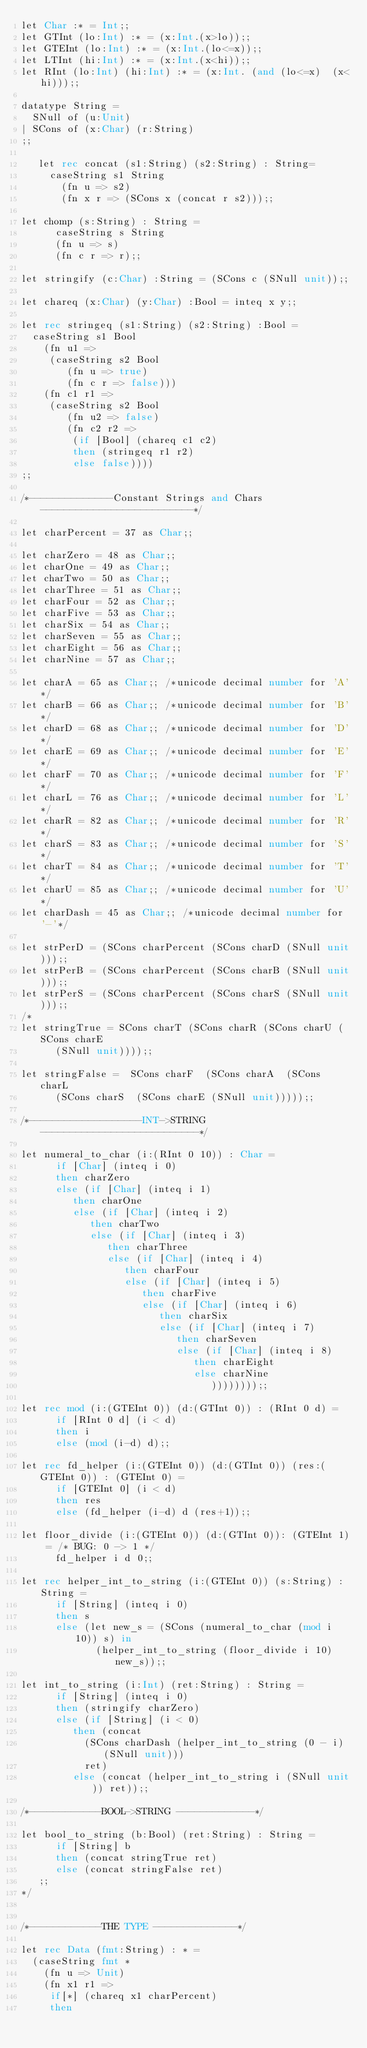Convert code to text. <code><loc_0><loc_0><loc_500><loc_500><_FORTRAN_>let Char :* = Int;;
let GTInt (lo:Int) :* = (x:Int.(x>lo));;
let GTEInt (lo:Int) :* = (x:Int.(lo<=x));;
let LTInt (hi:Int) :* = (x:Int.(x<hi));; 
let RInt (lo:Int) (hi:Int) :* = (x:Int. (and (lo<=x)  (x<hi)));;

datatype String =
  SNull of (u:Unit)
| SCons of (x:Char) (r:String)
;;
   
   let rec concat (s1:String) (s2:String) : String=
     caseString s1 String
       (fn u => s2)
       (fn x r => (SCons x (concat r s2)));;

let chomp (s:String) : String =
      caseString s String
      (fn u => s)
      (fn c r => r);;  

let stringify (c:Char) :String = (SCons c (SNull unit));;

let chareq (x:Char) (y:Char) :Bool = inteq x y;;

let rec stringeq (s1:String) (s2:String) :Bool = 
  caseString s1 Bool
    (fn u1 => 
     (caseString s2 Bool
        (fn u => true)
        (fn c r => false)))
    (fn c1 r1 => 
     (caseString s2 Bool
        (fn u2 => false)
        (fn c2 r2 => 
         (if [Bool] (chareq c1 c2)
         then (stringeq r1 r2)
         else false))))
;;

/*--------------Constant Strings and Chars--------------------------*/

let charPercent = 37 as Char;; 
    
let charZero = 48 as Char;;
let charOne = 49 as Char;;
let charTwo = 50 as Char;;
let charThree = 51 as Char;;
let charFour = 52 as Char;;
let charFive = 53 as Char;;
let charSix = 54 as Char;;
let charSeven = 55 as Char;;
let charEight = 56 as Char;;
let charNine = 57 as Char;;

let charA = 65 as Char;; /*unicode decimal number for 'A'*/
let charB = 66 as Char;; /*unicode decimal number for 'B'*/
let charD = 68 as Char;; /*unicode decimal number for 'D'*/
let charE = 69 as Char;; /*unicode decimal number for 'E'*/
let charF = 70 as Char;; /*unicode decimal number for 'F'*/
let charL = 76 as Char;; /*unicode decimal number for 'L'*/
let charR = 82 as Char;; /*unicode decimal number for 'R'*/
let charS = 83 as Char;; /*unicode decimal number for 'S'*/
let charT = 84 as Char;; /*unicode decimal number for 'T'*/
let charU = 85 as Char;; /*unicode decimal number for 'U'*/
let charDash = 45 as Char;; /*unicode decimal number for '-'*/

let strPerD = (SCons charPercent (SCons charD (SNull unit)));;
let strPerB = (SCons charPercent (SCons charB (SNull unit)));;
let strPerS = (SCons charPercent (SCons charS (SNull unit)));;
/*
let stringTrue = SCons charT (SCons charR (SCons charU (SCons charE 
      (SNull unit))));;

let stringFalse =  SCons charF  (SCons charA  (SCons charL  
      (SCons charS  (SCons charE (SNull unit)))));;

/*-------------------INT->STRING---------------------------*/
         
let numeral_to_char (i:(RInt 0 10)) : Char =
      if [Char] (inteq i 0)
      then charZero
      else (if [Char] (inteq i 1)
         then charOne
         else (if [Char] (inteq i 2)
            then charTwo
            else (if [Char] (inteq i 3)
               then charThree
               else (if [Char] (inteq i 4)
                  then charFour
                  else (if [Char] (inteq i 5)
                     then charFive
                     else (if [Char] (inteq i 6)
                        then charSix
                        else (if [Char] (inteq i 7)
                           then charSeven
                           else (if [Char] (inteq i 8)
                              then charEight
                              else charNine
                                 ))))))));;

let rec mod (i:(GTEInt 0)) (d:(GTInt 0)) : (RInt 0 d) =
      if [RInt 0 d] (i < d)
      then i
      else (mod (i-d) d);;

let rec fd_helper (i:(GTEInt 0)) (d:(GTInt 0)) (res:(GTEInt 0)) : (GTEInt 0) =
      if [GTEInt 0] (i < d)
      then res
      else (fd_helper (i-d) d (res+1));;

let floor_divide (i:(GTEInt 0)) (d:(GTInt 0)): (GTEInt 1) = /* BUG: 0 -> 1 */
      fd_helper i d 0;;

let rec helper_int_to_string (i:(GTEInt 0)) (s:String) : String = 
      if [String] (inteq i 0)
      then s
      else (let new_s = (SCons (numeral_to_char (mod i 10)) s) in
             (helper_int_to_string (floor_divide i 10) new_s));;

let int_to_string (i:Int) (ret:String) : String = 
      if [String] (inteq i 0) 
      then (stringify charZero)
      else (if [String] (i < 0) 
         then (concat 
           (SCons charDash (helper_int_to_string (0 - i) (SNull unit)))
           ret)
         else (concat (helper_int_to_string i (SNull unit)) ret));;

/*------------BOOL->STRING -------------*/

let bool_to_string (b:Bool) (ret:String) : String =
      if [String] b
      then (concat stringTrue ret)
      else (concat stringFalse ret)
   ;;
*/


/*------------THE TYPE --------------*/

let rec Data (fmt:String) : * =
  (caseString fmt *
    (fn u => Unit)
    (fn x1 r1 => 
     if[*] (chareq x1 charPercent) 
     then </code> 